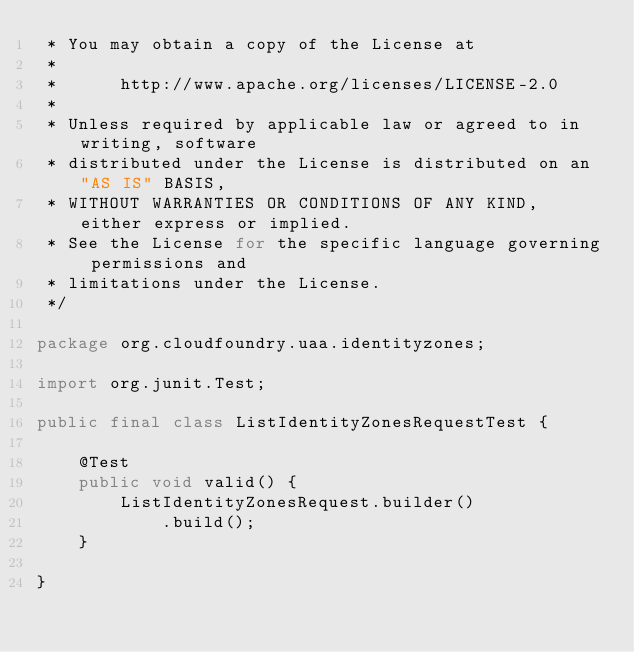<code> <loc_0><loc_0><loc_500><loc_500><_Java_> * You may obtain a copy of the License at
 *
 *      http://www.apache.org/licenses/LICENSE-2.0
 *
 * Unless required by applicable law or agreed to in writing, software
 * distributed under the License is distributed on an "AS IS" BASIS,
 * WITHOUT WARRANTIES OR CONDITIONS OF ANY KIND, either express or implied.
 * See the License for the specific language governing permissions and
 * limitations under the License.
 */

package org.cloudfoundry.uaa.identityzones;

import org.junit.Test;

public final class ListIdentityZonesRequestTest {

    @Test
    public void valid() {
        ListIdentityZonesRequest.builder()
            .build();
    }

}
</code> 